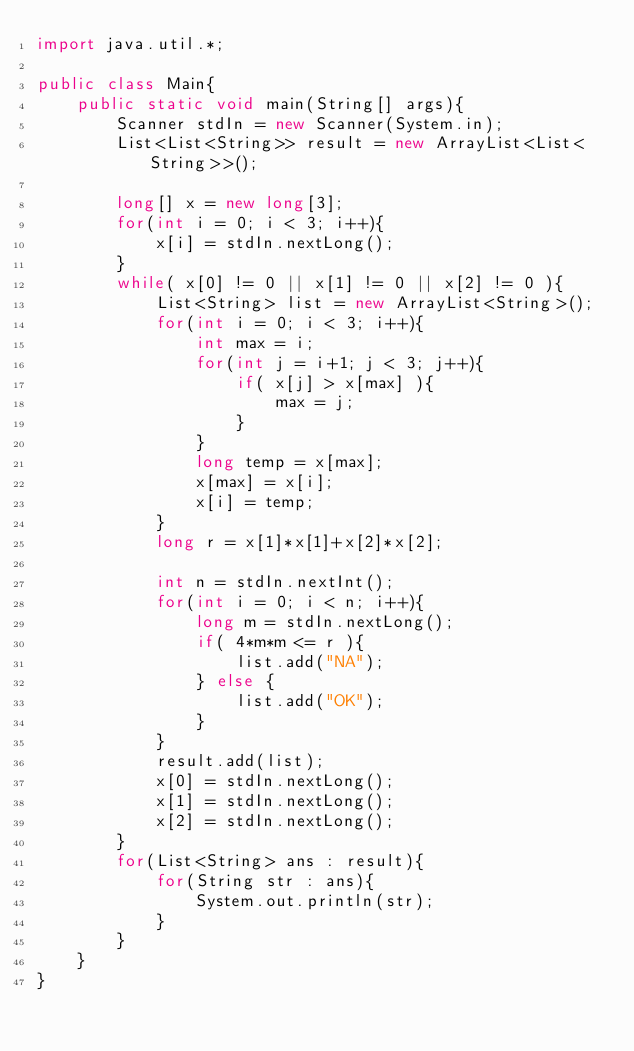<code> <loc_0><loc_0><loc_500><loc_500><_Java_>import java.util.*;

public class Main{
	public static void main(String[] args){
		Scanner stdIn = new Scanner(System.in);
		List<List<String>> result = new ArrayList<List<String>>();
		
		long[] x = new long[3];
		for(int i = 0; i < 3; i++){
			x[i] = stdIn.nextLong();
		}
		while( x[0] != 0 || x[1] != 0 || x[2] != 0 ){
			List<String> list = new ArrayList<String>();
			for(int i = 0; i < 3; i++){
				int max = i;
				for(int j = i+1; j < 3; j++){
					if( x[j] > x[max] ){
						max = j;
					}
				}
				long temp = x[max];
				x[max] = x[i];
				x[i] = temp;
			}
			long r = x[1]*x[1]+x[2]*x[2];
		
			int n = stdIn.nextInt();
			for(int i = 0; i < n; i++){
				long m = stdIn.nextLong();
				if( 4*m*m <= r ){
					list.add("NA");
				} else {
					list.add("OK");
				}
			}
			result.add(list);
			x[0] = stdIn.nextLong();
			x[1] = stdIn.nextLong();
			x[2] = stdIn.nextLong();
		}
		for(List<String> ans : result){
			for(String str : ans){
				System.out.println(str);
			}
		}
	}
}</code> 